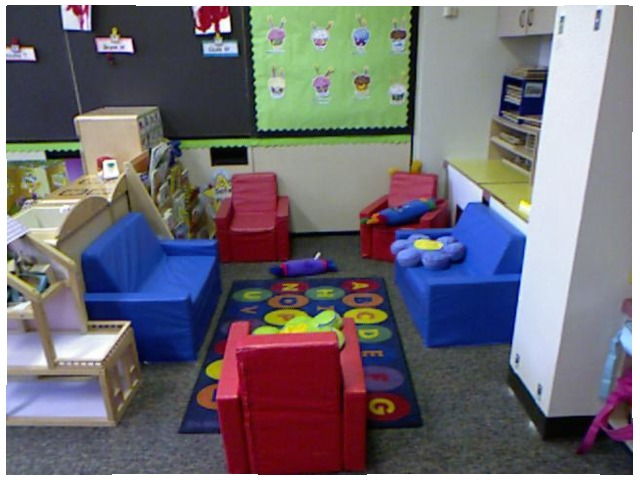<image>
Can you confirm if the pillow is in front of the chair? No. The pillow is not in front of the chair. The spatial positioning shows a different relationship between these objects. Where is the cupcake in relation to the wall? Is it on the wall? Yes. Looking at the image, I can see the cupcake is positioned on top of the wall, with the wall providing support. Is there a pillow on the chair? No. The pillow is not positioned on the chair. They may be near each other, but the pillow is not supported by or resting on top of the chair. Where is the flower in relation to the desk? Is it on the desk? No. The flower is not positioned on the desk. They may be near each other, but the flower is not supported by or resting on top of the desk. Where is the pillow in relation to the chair? Is it on the chair? No. The pillow is not positioned on the chair. They may be near each other, but the pillow is not supported by or resting on top of the chair. 